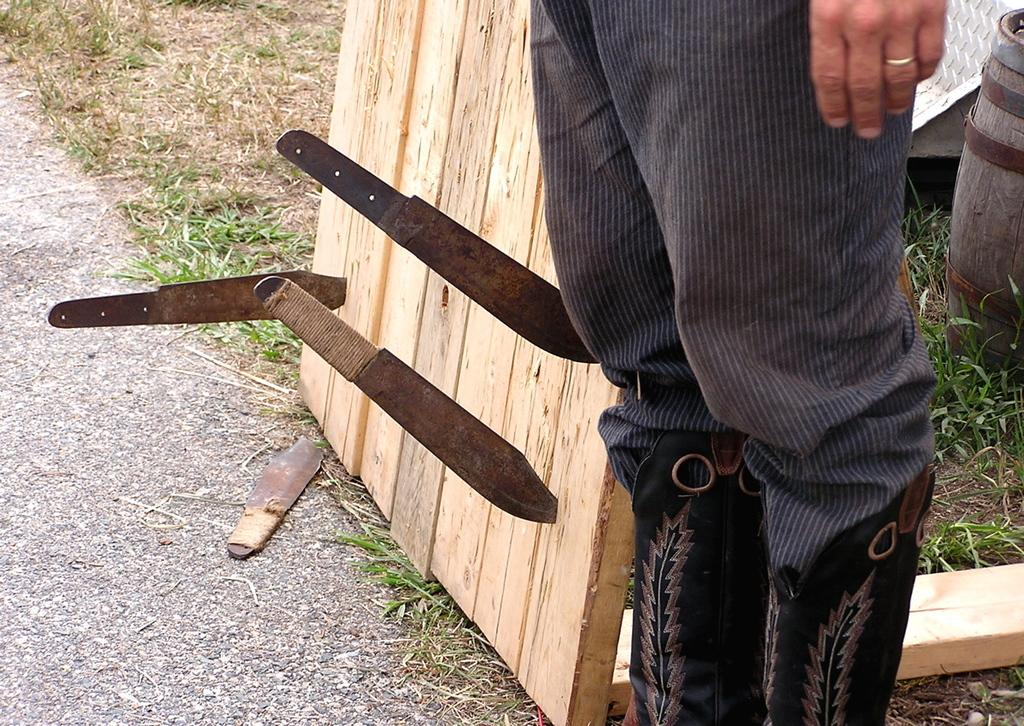What is the main subject of the image? There is a person standing in the image. What objects are on the table in the image? There are knives on the table. What type of container is in the right corner of the image? There is a wooden barrel in the right corner of the image. What type of natural environment is visible in the image? There is grass visible in the image. What type of system is being used to grow the rose in the image? There is no rose present in the image, so it is not possible to determine what type of system might be used to grow it. 